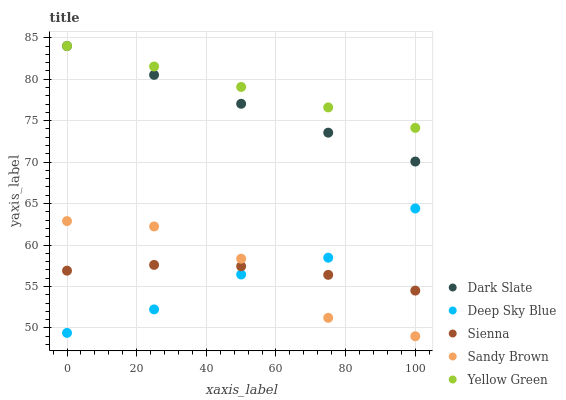Does Deep Sky Blue have the minimum area under the curve?
Answer yes or no. Yes. Does Yellow Green have the maximum area under the curve?
Answer yes or no. Yes. Does Dark Slate have the minimum area under the curve?
Answer yes or no. No. Does Dark Slate have the maximum area under the curve?
Answer yes or no. No. Is Dark Slate the smoothest?
Answer yes or no. Yes. Is Sandy Brown the roughest?
Answer yes or no. Yes. Is Sandy Brown the smoothest?
Answer yes or no. No. Is Dark Slate the roughest?
Answer yes or no. No. Does Sandy Brown have the lowest value?
Answer yes or no. Yes. Does Dark Slate have the lowest value?
Answer yes or no. No. Does Yellow Green have the highest value?
Answer yes or no. Yes. Does Sandy Brown have the highest value?
Answer yes or no. No. Is Sienna less than Yellow Green?
Answer yes or no. Yes. Is Dark Slate greater than Sienna?
Answer yes or no. Yes. Does Deep Sky Blue intersect Sienna?
Answer yes or no. Yes. Is Deep Sky Blue less than Sienna?
Answer yes or no. No. Is Deep Sky Blue greater than Sienna?
Answer yes or no. No. Does Sienna intersect Yellow Green?
Answer yes or no. No. 